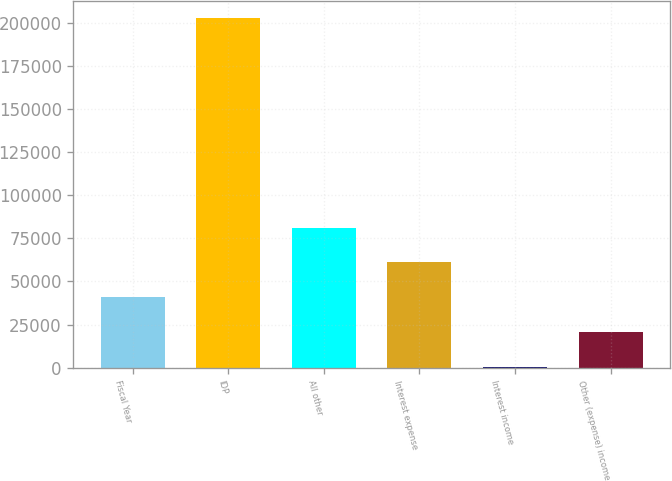Convert chart to OTSL. <chart><loc_0><loc_0><loc_500><loc_500><bar_chart><fcel>Fiscal Year<fcel>IDP<fcel>All other<fcel>Interest expense<fcel>Interest income<fcel>Other (expense) income<nl><fcel>40743.6<fcel>202722<fcel>81238.2<fcel>60990.9<fcel>249<fcel>20496.3<nl></chart> 